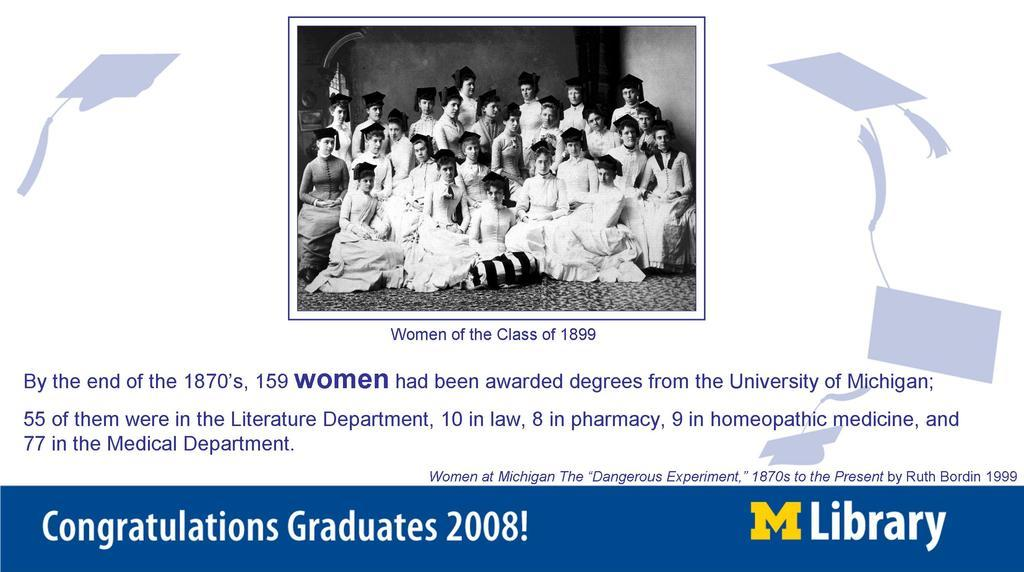What type of image is being described? The image is a poster. What can be seen in the photo on the poster? There is a photo of a group of people on the poster. What else is present on the poster besides the photo? There is text on the poster. How many teeth can be seen in the photo of the group of people on the poster? There are no teeth visible in the photo of the group of people on the poster, as it is a photo of people and not a close-up of their teeth. 